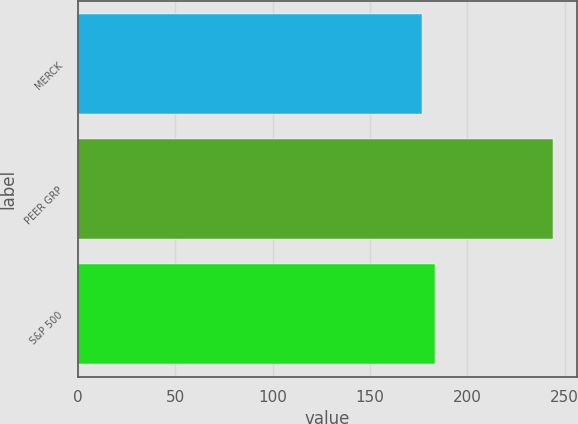Convert chart. <chart><loc_0><loc_0><loc_500><loc_500><bar_chart><fcel>MERCK<fcel>PEER GRP<fcel>S&P 500<nl><fcel>176.53<fcel>244.08<fcel>183.28<nl></chart> 